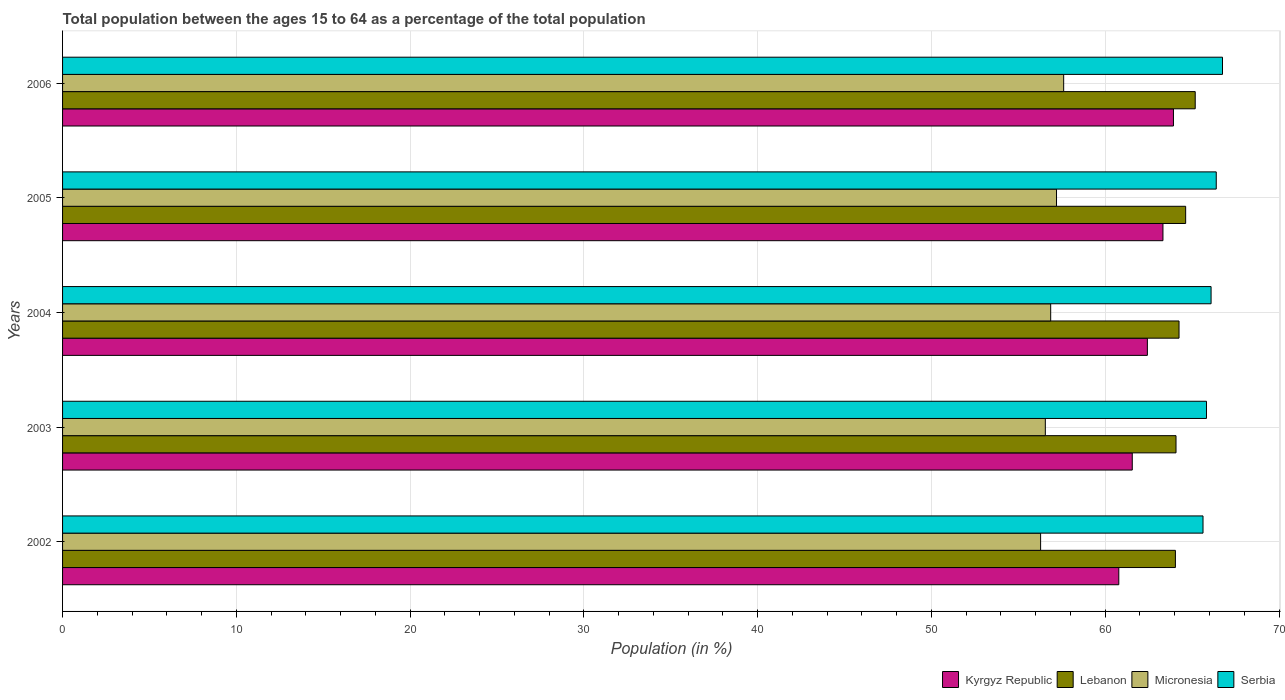How many groups of bars are there?
Provide a succinct answer. 5. Are the number of bars per tick equal to the number of legend labels?
Ensure brevity in your answer.  Yes. How many bars are there on the 4th tick from the bottom?
Offer a terse response. 4. What is the label of the 3rd group of bars from the top?
Provide a succinct answer. 2004. What is the percentage of the population ages 15 to 64 in Kyrgyz Republic in 2002?
Your response must be concise. 60.78. Across all years, what is the maximum percentage of the population ages 15 to 64 in Kyrgyz Republic?
Keep it short and to the point. 63.93. Across all years, what is the minimum percentage of the population ages 15 to 64 in Kyrgyz Republic?
Provide a short and direct response. 60.78. In which year was the percentage of the population ages 15 to 64 in Serbia maximum?
Your answer should be very brief. 2006. In which year was the percentage of the population ages 15 to 64 in Serbia minimum?
Provide a short and direct response. 2002. What is the total percentage of the population ages 15 to 64 in Serbia in the graph?
Give a very brief answer. 330.68. What is the difference between the percentage of the population ages 15 to 64 in Lebanon in 2002 and that in 2006?
Your answer should be compact. -1.14. What is the difference between the percentage of the population ages 15 to 64 in Serbia in 2004 and the percentage of the population ages 15 to 64 in Lebanon in 2005?
Offer a very short reply. 1.46. What is the average percentage of the population ages 15 to 64 in Micronesia per year?
Your response must be concise. 56.9. In the year 2003, what is the difference between the percentage of the population ages 15 to 64 in Serbia and percentage of the population ages 15 to 64 in Kyrgyz Republic?
Give a very brief answer. 4.27. What is the ratio of the percentage of the population ages 15 to 64 in Kyrgyz Republic in 2004 to that in 2006?
Offer a terse response. 0.98. Is the percentage of the population ages 15 to 64 in Lebanon in 2003 less than that in 2005?
Your answer should be compact. Yes. Is the difference between the percentage of the population ages 15 to 64 in Serbia in 2002 and 2006 greater than the difference between the percentage of the population ages 15 to 64 in Kyrgyz Republic in 2002 and 2006?
Your answer should be very brief. Yes. What is the difference between the highest and the second highest percentage of the population ages 15 to 64 in Lebanon?
Offer a terse response. 0.55. What is the difference between the highest and the lowest percentage of the population ages 15 to 64 in Micronesia?
Make the answer very short. 1.33. Is the sum of the percentage of the population ages 15 to 64 in Kyrgyz Republic in 2005 and 2006 greater than the maximum percentage of the population ages 15 to 64 in Lebanon across all years?
Keep it short and to the point. Yes. Is it the case that in every year, the sum of the percentage of the population ages 15 to 64 in Lebanon and percentage of the population ages 15 to 64 in Micronesia is greater than the sum of percentage of the population ages 15 to 64 in Serbia and percentage of the population ages 15 to 64 in Kyrgyz Republic?
Give a very brief answer. No. What does the 2nd bar from the top in 2003 represents?
Offer a very short reply. Micronesia. What does the 2nd bar from the bottom in 2006 represents?
Your response must be concise. Lebanon. How many years are there in the graph?
Keep it short and to the point. 5. What is the difference between two consecutive major ticks on the X-axis?
Provide a succinct answer. 10. Does the graph contain any zero values?
Offer a terse response. No. Where does the legend appear in the graph?
Offer a terse response. Bottom right. How many legend labels are there?
Your response must be concise. 4. How are the legend labels stacked?
Offer a terse response. Horizontal. What is the title of the graph?
Your answer should be compact. Total population between the ages 15 to 64 as a percentage of the total population. What is the Population (in %) of Kyrgyz Republic in 2002?
Your response must be concise. 60.78. What is the Population (in %) of Lebanon in 2002?
Ensure brevity in your answer.  64.04. What is the Population (in %) of Micronesia in 2002?
Keep it short and to the point. 56.28. What is the Population (in %) in Serbia in 2002?
Give a very brief answer. 65.63. What is the Population (in %) of Kyrgyz Republic in 2003?
Offer a very short reply. 61.56. What is the Population (in %) of Lebanon in 2003?
Offer a terse response. 64.07. What is the Population (in %) in Micronesia in 2003?
Ensure brevity in your answer.  56.55. What is the Population (in %) of Serbia in 2003?
Your response must be concise. 65.83. What is the Population (in %) of Kyrgyz Republic in 2004?
Keep it short and to the point. 62.43. What is the Population (in %) of Lebanon in 2004?
Your answer should be very brief. 64.25. What is the Population (in %) in Micronesia in 2004?
Your response must be concise. 56.86. What is the Population (in %) in Serbia in 2004?
Offer a terse response. 66.09. What is the Population (in %) of Kyrgyz Republic in 2005?
Provide a short and direct response. 63.32. What is the Population (in %) in Lebanon in 2005?
Your answer should be compact. 64.63. What is the Population (in %) in Micronesia in 2005?
Your answer should be very brief. 57.2. What is the Population (in %) of Serbia in 2005?
Offer a terse response. 66.39. What is the Population (in %) in Kyrgyz Republic in 2006?
Ensure brevity in your answer.  63.93. What is the Population (in %) in Lebanon in 2006?
Provide a short and direct response. 65.18. What is the Population (in %) of Micronesia in 2006?
Give a very brief answer. 57.61. What is the Population (in %) in Serbia in 2006?
Ensure brevity in your answer.  66.75. Across all years, what is the maximum Population (in %) of Kyrgyz Republic?
Offer a terse response. 63.93. Across all years, what is the maximum Population (in %) of Lebanon?
Provide a short and direct response. 65.18. Across all years, what is the maximum Population (in %) of Micronesia?
Provide a succinct answer. 57.61. Across all years, what is the maximum Population (in %) in Serbia?
Keep it short and to the point. 66.75. Across all years, what is the minimum Population (in %) of Kyrgyz Republic?
Your answer should be very brief. 60.78. Across all years, what is the minimum Population (in %) in Lebanon?
Provide a short and direct response. 64.04. Across all years, what is the minimum Population (in %) of Micronesia?
Provide a short and direct response. 56.28. Across all years, what is the minimum Population (in %) of Serbia?
Your answer should be compact. 65.63. What is the total Population (in %) in Kyrgyz Republic in the graph?
Provide a short and direct response. 312.01. What is the total Population (in %) in Lebanon in the graph?
Offer a terse response. 322.17. What is the total Population (in %) of Micronesia in the graph?
Offer a very short reply. 284.5. What is the total Population (in %) in Serbia in the graph?
Make the answer very short. 330.68. What is the difference between the Population (in %) in Kyrgyz Republic in 2002 and that in 2003?
Your answer should be very brief. -0.78. What is the difference between the Population (in %) of Lebanon in 2002 and that in 2003?
Make the answer very short. -0.04. What is the difference between the Population (in %) in Micronesia in 2002 and that in 2003?
Offer a very short reply. -0.27. What is the difference between the Population (in %) of Serbia in 2002 and that in 2003?
Provide a succinct answer. -0.2. What is the difference between the Population (in %) of Kyrgyz Republic in 2002 and that in 2004?
Give a very brief answer. -1.64. What is the difference between the Population (in %) in Lebanon in 2002 and that in 2004?
Keep it short and to the point. -0.21. What is the difference between the Population (in %) in Micronesia in 2002 and that in 2004?
Provide a succinct answer. -0.58. What is the difference between the Population (in %) in Serbia in 2002 and that in 2004?
Your answer should be very brief. -0.46. What is the difference between the Population (in %) in Kyrgyz Republic in 2002 and that in 2005?
Provide a short and direct response. -2.54. What is the difference between the Population (in %) of Lebanon in 2002 and that in 2005?
Make the answer very short. -0.59. What is the difference between the Population (in %) in Micronesia in 2002 and that in 2005?
Your answer should be compact. -0.92. What is the difference between the Population (in %) in Serbia in 2002 and that in 2005?
Make the answer very short. -0.76. What is the difference between the Population (in %) in Kyrgyz Republic in 2002 and that in 2006?
Offer a terse response. -3.15. What is the difference between the Population (in %) in Lebanon in 2002 and that in 2006?
Your response must be concise. -1.14. What is the difference between the Population (in %) of Micronesia in 2002 and that in 2006?
Keep it short and to the point. -1.33. What is the difference between the Population (in %) of Serbia in 2002 and that in 2006?
Provide a succinct answer. -1.12. What is the difference between the Population (in %) of Kyrgyz Republic in 2003 and that in 2004?
Ensure brevity in your answer.  -0.87. What is the difference between the Population (in %) of Lebanon in 2003 and that in 2004?
Offer a very short reply. -0.17. What is the difference between the Population (in %) of Micronesia in 2003 and that in 2004?
Offer a very short reply. -0.31. What is the difference between the Population (in %) of Serbia in 2003 and that in 2004?
Offer a very short reply. -0.26. What is the difference between the Population (in %) of Kyrgyz Republic in 2003 and that in 2005?
Ensure brevity in your answer.  -1.77. What is the difference between the Population (in %) in Lebanon in 2003 and that in 2005?
Make the answer very short. -0.55. What is the difference between the Population (in %) in Micronesia in 2003 and that in 2005?
Offer a very short reply. -0.64. What is the difference between the Population (in %) of Serbia in 2003 and that in 2005?
Provide a short and direct response. -0.56. What is the difference between the Population (in %) in Kyrgyz Republic in 2003 and that in 2006?
Your answer should be very brief. -2.37. What is the difference between the Population (in %) in Lebanon in 2003 and that in 2006?
Offer a terse response. -1.11. What is the difference between the Population (in %) of Micronesia in 2003 and that in 2006?
Make the answer very short. -1.06. What is the difference between the Population (in %) of Serbia in 2003 and that in 2006?
Keep it short and to the point. -0.92. What is the difference between the Population (in %) of Kyrgyz Republic in 2004 and that in 2005?
Offer a very short reply. -0.9. What is the difference between the Population (in %) in Lebanon in 2004 and that in 2005?
Offer a very short reply. -0.38. What is the difference between the Population (in %) in Micronesia in 2004 and that in 2005?
Offer a terse response. -0.34. What is the difference between the Population (in %) of Serbia in 2004 and that in 2005?
Your response must be concise. -0.3. What is the difference between the Population (in %) of Kyrgyz Republic in 2004 and that in 2006?
Ensure brevity in your answer.  -1.5. What is the difference between the Population (in %) in Lebanon in 2004 and that in 2006?
Keep it short and to the point. -0.93. What is the difference between the Population (in %) of Micronesia in 2004 and that in 2006?
Make the answer very short. -0.75. What is the difference between the Population (in %) in Serbia in 2004 and that in 2006?
Your answer should be compact. -0.66. What is the difference between the Population (in %) of Kyrgyz Republic in 2005 and that in 2006?
Provide a short and direct response. -0.6. What is the difference between the Population (in %) in Lebanon in 2005 and that in 2006?
Provide a short and direct response. -0.55. What is the difference between the Population (in %) in Micronesia in 2005 and that in 2006?
Make the answer very short. -0.41. What is the difference between the Population (in %) in Serbia in 2005 and that in 2006?
Provide a short and direct response. -0.36. What is the difference between the Population (in %) in Kyrgyz Republic in 2002 and the Population (in %) in Lebanon in 2003?
Ensure brevity in your answer.  -3.29. What is the difference between the Population (in %) in Kyrgyz Republic in 2002 and the Population (in %) in Micronesia in 2003?
Keep it short and to the point. 4.23. What is the difference between the Population (in %) in Kyrgyz Republic in 2002 and the Population (in %) in Serbia in 2003?
Give a very brief answer. -5.05. What is the difference between the Population (in %) of Lebanon in 2002 and the Population (in %) of Micronesia in 2003?
Your answer should be very brief. 7.48. What is the difference between the Population (in %) of Lebanon in 2002 and the Population (in %) of Serbia in 2003?
Your response must be concise. -1.79. What is the difference between the Population (in %) of Micronesia in 2002 and the Population (in %) of Serbia in 2003?
Your answer should be compact. -9.55. What is the difference between the Population (in %) in Kyrgyz Republic in 2002 and the Population (in %) in Lebanon in 2004?
Make the answer very short. -3.47. What is the difference between the Population (in %) of Kyrgyz Republic in 2002 and the Population (in %) of Micronesia in 2004?
Your response must be concise. 3.92. What is the difference between the Population (in %) of Kyrgyz Republic in 2002 and the Population (in %) of Serbia in 2004?
Ensure brevity in your answer.  -5.31. What is the difference between the Population (in %) of Lebanon in 2002 and the Population (in %) of Micronesia in 2004?
Give a very brief answer. 7.18. What is the difference between the Population (in %) in Lebanon in 2002 and the Population (in %) in Serbia in 2004?
Offer a very short reply. -2.05. What is the difference between the Population (in %) in Micronesia in 2002 and the Population (in %) in Serbia in 2004?
Your answer should be compact. -9.81. What is the difference between the Population (in %) of Kyrgyz Republic in 2002 and the Population (in %) of Lebanon in 2005?
Keep it short and to the point. -3.85. What is the difference between the Population (in %) in Kyrgyz Republic in 2002 and the Population (in %) in Micronesia in 2005?
Provide a short and direct response. 3.58. What is the difference between the Population (in %) of Kyrgyz Republic in 2002 and the Population (in %) of Serbia in 2005?
Offer a terse response. -5.61. What is the difference between the Population (in %) of Lebanon in 2002 and the Population (in %) of Micronesia in 2005?
Provide a short and direct response. 6.84. What is the difference between the Population (in %) in Lebanon in 2002 and the Population (in %) in Serbia in 2005?
Ensure brevity in your answer.  -2.35. What is the difference between the Population (in %) in Micronesia in 2002 and the Population (in %) in Serbia in 2005?
Give a very brief answer. -10.11. What is the difference between the Population (in %) in Kyrgyz Republic in 2002 and the Population (in %) in Lebanon in 2006?
Your answer should be very brief. -4.4. What is the difference between the Population (in %) of Kyrgyz Republic in 2002 and the Population (in %) of Micronesia in 2006?
Make the answer very short. 3.17. What is the difference between the Population (in %) of Kyrgyz Republic in 2002 and the Population (in %) of Serbia in 2006?
Make the answer very short. -5.97. What is the difference between the Population (in %) of Lebanon in 2002 and the Population (in %) of Micronesia in 2006?
Your response must be concise. 6.43. What is the difference between the Population (in %) in Lebanon in 2002 and the Population (in %) in Serbia in 2006?
Offer a very short reply. -2.71. What is the difference between the Population (in %) of Micronesia in 2002 and the Population (in %) of Serbia in 2006?
Provide a short and direct response. -10.47. What is the difference between the Population (in %) in Kyrgyz Republic in 2003 and the Population (in %) in Lebanon in 2004?
Your answer should be compact. -2.69. What is the difference between the Population (in %) of Kyrgyz Republic in 2003 and the Population (in %) of Micronesia in 2004?
Ensure brevity in your answer.  4.69. What is the difference between the Population (in %) of Kyrgyz Republic in 2003 and the Population (in %) of Serbia in 2004?
Your answer should be very brief. -4.54. What is the difference between the Population (in %) in Lebanon in 2003 and the Population (in %) in Micronesia in 2004?
Keep it short and to the point. 7.21. What is the difference between the Population (in %) in Lebanon in 2003 and the Population (in %) in Serbia in 2004?
Provide a short and direct response. -2.02. What is the difference between the Population (in %) in Micronesia in 2003 and the Population (in %) in Serbia in 2004?
Your answer should be compact. -9.54. What is the difference between the Population (in %) of Kyrgyz Republic in 2003 and the Population (in %) of Lebanon in 2005?
Make the answer very short. -3.07. What is the difference between the Population (in %) in Kyrgyz Republic in 2003 and the Population (in %) in Micronesia in 2005?
Ensure brevity in your answer.  4.36. What is the difference between the Population (in %) of Kyrgyz Republic in 2003 and the Population (in %) of Serbia in 2005?
Keep it short and to the point. -4.83. What is the difference between the Population (in %) in Lebanon in 2003 and the Population (in %) in Micronesia in 2005?
Give a very brief answer. 6.88. What is the difference between the Population (in %) of Lebanon in 2003 and the Population (in %) of Serbia in 2005?
Your answer should be compact. -2.32. What is the difference between the Population (in %) in Micronesia in 2003 and the Population (in %) in Serbia in 2005?
Provide a succinct answer. -9.84. What is the difference between the Population (in %) of Kyrgyz Republic in 2003 and the Population (in %) of Lebanon in 2006?
Give a very brief answer. -3.62. What is the difference between the Population (in %) of Kyrgyz Republic in 2003 and the Population (in %) of Micronesia in 2006?
Provide a short and direct response. 3.95. What is the difference between the Population (in %) in Kyrgyz Republic in 2003 and the Population (in %) in Serbia in 2006?
Give a very brief answer. -5.19. What is the difference between the Population (in %) of Lebanon in 2003 and the Population (in %) of Micronesia in 2006?
Keep it short and to the point. 6.46. What is the difference between the Population (in %) in Lebanon in 2003 and the Population (in %) in Serbia in 2006?
Provide a succinct answer. -2.68. What is the difference between the Population (in %) in Micronesia in 2003 and the Population (in %) in Serbia in 2006?
Give a very brief answer. -10.19. What is the difference between the Population (in %) in Kyrgyz Republic in 2004 and the Population (in %) in Lebanon in 2005?
Your response must be concise. -2.2. What is the difference between the Population (in %) of Kyrgyz Republic in 2004 and the Population (in %) of Micronesia in 2005?
Offer a very short reply. 5.23. What is the difference between the Population (in %) in Kyrgyz Republic in 2004 and the Population (in %) in Serbia in 2005?
Keep it short and to the point. -3.96. What is the difference between the Population (in %) of Lebanon in 2004 and the Population (in %) of Micronesia in 2005?
Provide a succinct answer. 7.05. What is the difference between the Population (in %) of Lebanon in 2004 and the Population (in %) of Serbia in 2005?
Offer a terse response. -2.14. What is the difference between the Population (in %) in Micronesia in 2004 and the Population (in %) in Serbia in 2005?
Give a very brief answer. -9.53. What is the difference between the Population (in %) in Kyrgyz Republic in 2004 and the Population (in %) in Lebanon in 2006?
Provide a short and direct response. -2.75. What is the difference between the Population (in %) in Kyrgyz Republic in 2004 and the Population (in %) in Micronesia in 2006?
Provide a succinct answer. 4.82. What is the difference between the Population (in %) in Kyrgyz Republic in 2004 and the Population (in %) in Serbia in 2006?
Offer a terse response. -4.32. What is the difference between the Population (in %) in Lebanon in 2004 and the Population (in %) in Micronesia in 2006?
Provide a short and direct response. 6.64. What is the difference between the Population (in %) in Lebanon in 2004 and the Population (in %) in Serbia in 2006?
Give a very brief answer. -2.5. What is the difference between the Population (in %) in Micronesia in 2004 and the Population (in %) in Serbia in 2006?
Ensure brevity in your answer.  -9.89. What is the difference between the Population (in %) in Kyrgyz Republic in 2005 and the Population (in %) in Lebanon in 2006?
Offer a very short reply. -1.86. What is the difference between the Population (in %) of Kyrgyz Republic in 2005 and the Population (in %) of Micronesia in 2006?
Make the answer very short. 5.71. What is the difference between the Population (in %) of Kyrgyz Republic in 2005 and the Population (in %) of Serbia in 2006?
Ensure brevity in your answer.  -3.43. What is the difference between the Population (in %) in Lebanon in 2005 and the Population (in %) in Micronesia in 2006?
Give a very brief answer. 7.02. What is the difference between the Population (in %) of Lebanon in 2005 and the Population (in %) of Serbia in 2006?
Your response must be concise. -2.12. What is the difference between the Population (in %) in Micronesia in 2005 and the Population (in %) in Serbia in 2006?
Your answer should be very brief. -9.55. What is the average Population (in %) of Kyrgyz Republic per year?
Keep it short and to the point. 62.4. What is the average Population (in %) in Lebanon per year?
Offer a very short reply. 64.43. What is the average Population (in %) in Micronesia per year?
Your answer should be very brief. 56.9. What is the average Population (in %) of Serbia per year?
Ensure brevity in your answer.  66.14. In the year 2002, what is the difference between the Population (in %) in Kyrgyz Republic and Population (in %) in Lebanon?
Your answer should be compact. -3.26. In the year 2002, what is the difference between the Population (in %) in Kyrgyz Republic and Population (in %) in Micronesia?
Provide a succinct answer. 4.5. In the year 2002, what is the difference between the Population (in %) of Kyrgyz Republic and Population (in %) of Serbia?
Your response must be concise. -4.85. In the year 2002, what is the difference between the Population (in %) in Lebanon and Population (in %) in Micronesia?
Offer a terse response. 7.76. In the year 2002, what is the difference between the Population (in %) in Lebanon and Population (in %) in Serbia?
Your answer should be very brief. -1.59. In the year 2002, what is the difference between the Population (in %) of Micronesia and Population (in %) of Serbia?
Ensure brevity in your answer.  -9.35. In the year 2003, what is the difference between the Population (in %) in Kyrgyz Republic and Population (in %) in Lebanon?
Your response must be concise. -2.52. In the year 2003, what is the difference between the Population (in %) in Kyrgyz Republic and Population (in %) in Micronesia?
Give a very brief answer. 5. In the year 2003, what is the difference between the Population (in %) of Kyrgyz Republic and Population (in %) of Serbia?
Your answer should be compact. -4.27. In the year 2003, what is the difference between the Population (in %) of Lebanon and Population (in %) of Micronesia?
Give a very brief answer. 7.52. In the year 2003, what is the difference between the Population (in %) of Lebanon and Population (in %) of Serbia?
Keep it short and to the point. -1.75. In the year 2003, what is the difference between the Population (in %) of Micronesia and Population (in %) of Serbia?
Ensure brevity in your answer.  -9.27. In the year 2004, what is the difference between the Population (in %) of Kyrgyz Republic and Population (in %) of Lebanon?
Offer a very short reply. -1.82. In the year 2004, what is the difference between the Population (in %) of Kyrgyz Republic and Population (in %) of Micronesia?
Your answer should be compact. 5.56. In the year 2004, what is the difference between the Population (in %) of Kyrgyz Republic and Population (in %) of Serbia?
Your answer should be very brief. -3.67. In the year 2004, what is the difference between the Population (in %) in Lebanon and Population (in %) in Micronesia?
Give a very brief answer. 7.39. In the year 2004, what is the difference between the Population (in %) in Lebanon and Population (in %) in Serbia?
Give a very brief answer. -1.84. In the year 2004, what is the difference between the Population (in %) of Micronesia and Population (in %) of Serbia?
Your answer should be very brief. -9.23. In the year 2005, what is the difference between the Population (in %) in Kyrgyz Republic and Population (in %) in Lebanon?
Keep it short and to the point. -1.31. In the year 2005, what is the difference between the Population (in %) in Kyrgyz Republic and Population (in %) in Micronesia?
Your answer should be compact. 6.13. In the year 2005, what is the difference between the Population (in %) of Kyrgyz Republic and Population (in %) of Serbia?
Your answer should be compact. -3.07. In the year 2005, what is the difference between the Population (in %) in Lebanon and Population (in %) in Micronesia?
Offer a very short reply. 7.43. In the year 2005, what is the difference between the Population (in %) of Lebanon and Population (in %) of Serbia?
Keep it short and to the point. -1.76. In the year 2005, what is the difference between the Population (in %) of Micronesia and Population (in %) of Serbia?
Keep it short and to the point. -9.19. In the year 2006, what is the difference between the Population (in %) of Kyrgyz Republic and Population (in %) of Lebanon?
Offer a very short reply. -1.25. In the year 2006, what is the difference between the Population (in %) of Kyrgyz Republic and Population (in %) of Micronesia?
Make the answer very short. 6.32. In the year 2006, what is the difference between the Population (in %) of Kyrgyz Republic and Population (in %) of Serbia?
Offer a very short reply. -2.82. In the year 2006, what is the difference between the Population (in %) of Lebanon and Population (in %) of Micronesia?
Your answer should be very brief. 7.57. In the year 2006, what is the difference between the Population (in %) of Lebanon and Population (in %) of Serbia?
Offer a very short reply. -1.57. In the year 2006, what is the difference between the Population (in %) of Micronesia and Population (in %) of Serbia?
Ensure brevity in your answer.  -9.14. What is the ratio of the Population (in %) of Kyrgyz Republic in 2002 to that in 2003?
Your response must be concise. 0.99. What is the ratio of the Population (in %) of Lebanon in 2002 to that in 2003?
Provide a succinct answer. 1. What is the ratio of the Population (in %) in Micronesia in 2002 to that in 2003?
Your answer should be very brief. 1. What is the ratio of the Population (in %) of Kyrgyz Republic in 2002 to that in 2004?
Provide a short and direct response. 0.97. What is the ratio of the Population (in %) of Lebanon in 2002 to that in 2004?
Your answer should be compact. 1. What is the ratio of the Population (in %) in Kyrgyz Republic in 2002 to that in 2005?
Keep it short and to the point. 0.96. What is the ratio of the Population (in %) in Lebanon in 2002 to that in 2005?
Your response must be concise. 0.99. What is the ratio of the Population (in %) of Micronesia in 2002 to that in 2005?
Your answer should be very brief. 0.98. What is the ratio of the Population (in %) of Kyrgyz Republic in 2002 to that in 2006?
Offer a terse response. 0.95. What is the ratio of the Population (in %) in Lebanon in 2002 to that in 2006?
Offer a terse response. 0.98. What is the ratio of the Population (in %) in Micronesia in 2002 to that in 2006?
Offer a very short reply. 0.98. What is the ratio of the Population (in %) of Serbia in 2002 to that in 2006?
Offer a terse response. 0.98. What is the ratio of the Population (in %) of Kyrgyz Republic in 2003 to that in 2004?
Offer a terse response. 0.99. What is the ratio of the Population (in %) of Micronesia in 2003 to that in 2004?
Offer a terse response. 0.99. What is the ratio of the Population (in %) of Serbia in 2003 to that in 2004?
Your answer should be very brief. 1. What is the ratio of the Population (in %) in Kyrgyz Republic in 2003 to that in 2005?
Provide a succinct answer. 0.97. What is the ratio of the Population (in %) in Micronesia in 2003 to that in 2005?
Keep it short and to the point. 0.99. What is the ratio of the Population (in %) in Kyrgyz Republic in 2003 to that in 2006?
Offer a very short reply. 0.96. What is the ratio of the Population (in %) of Micronesia in 2003 to that in 2006?
Make the answer very short. 0.98. What is the ratio of the Population (in %) in Serbia in 2003 to that in 2006?
Your response must be concise. 0.99. What is the ratio of the Population (in %) in Kyrgyz Republic in 2004 to that in 2005?
Offer a terse response. 0.99. What is the ratio of the Population (in %) in Micronesia in 2004 to that in 2005?
Provide a succinct answer. 0.99. What is the ratio of the Population (in %) of Serbia in 2004 to that in 2005?
Your answer should be compact. 1. What is the ratio of the Population (in %) in Kyrgyz Republic in 2004 to that in 2006?
Offer a very short reply. 0.98. What is the ratio of the Population (in %) of Lebanon in 2004 to that in 2006?
Keep it short and to the point. 0.99. What is the ratio of the Population (in %) in Serbia in 2004 to that in 2006?
Ensure brevity in your answer.  0.99. What is the ratio of the Population (in %) in Lebanon in 2005 to that in 2006?
Give a very brief answer. 0.99. What is the difference between the highest and the second highest Population (in %) in Kyrgyz Republic?
Give a very brief answer. 0.6. What is the difference between the highest and the second highest Population (in %) in Lebanon?
Provide a short and direct response. 0.55. What is the difference between the highest and the second highest Population (in %) in Micronesia?
Give a very brief answer. 0.41. What is the difference between the highest and the second highest Population (in %) in Serbia?
Keep it short and to the point. 0.36. What is the difference between the highest and the lowest Population (in %) in Kyrgyz Republic?
Keep it short and to the point. 3.15. What is the difference between the highest and the lowest Population (in %) of Lebanon?
Your answer should be compact. 1.14. What is the difference between the highest and the lowest Population (in %) in Micronesia?
Make the answer very short. 1.33. What is the difference between the highest and the lowest Population (in %) in Serbia?
Give a very brief answer. 1.12. 